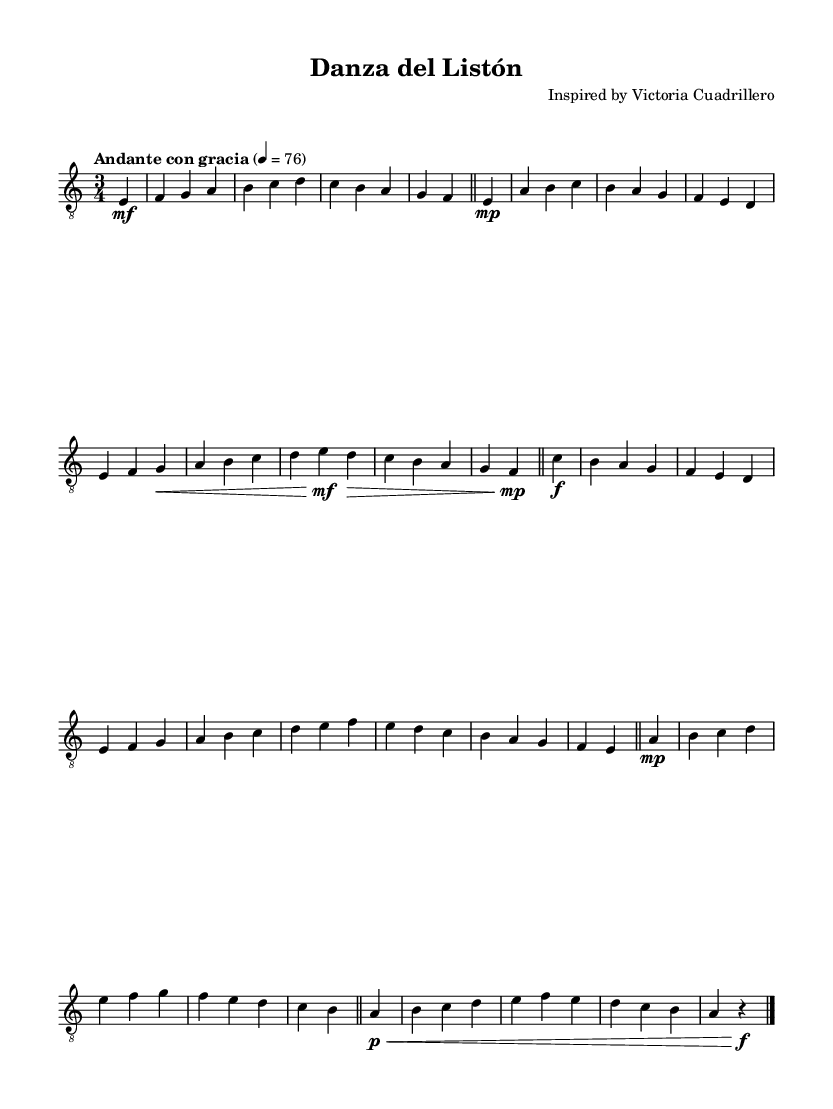What is the key signature of this music? The key signature is A minor, which has no sharps or flats. It can be identified by the absence of any accidentals indicated at the beginning of the staff after the clef.
Answer: A minor What is the time signature of this piece? The time signature is 3/4, which can be observed immediately after the clef and before the notes, indicating three beats per measure and a quarter note receives one beat.
Answer: 3/4 What is the tempo marking for this music? The tempo marking is "Andante con gracia," which is written above the staff and indicates a moderately slow tempo with grace.
Answer: Andante con gracia How many themes are presented in the music? There are three distinct themes labeled A, B, and C in the music. This can be deduced from observing markings or the musical structure where each theme has a specific melodic pattern.
Answer: Three Which theme appears first in the score? Theme A appears first in the score, as it is the initial set of musical notes presented following the introduction section. The presence of theme labels indicates the order of themes.
Answer: Theme A What is the dynamic marking at the beginning of Theme A? The dynamic marking at the beginning of Theme A is "mp," which is a common dynamic marking indicating a mezzo-piano, or moderately soft volume level. This marking is noted at the beginning of the theme section.
Answer: mp 